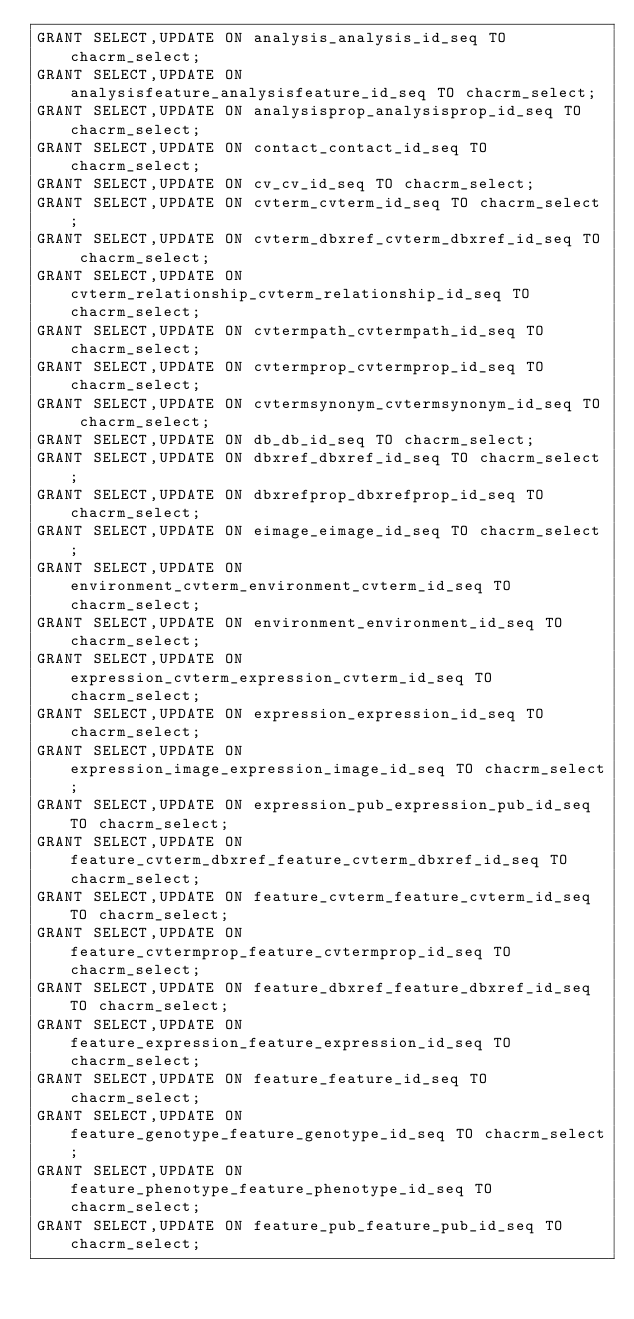<code> <loc_0><loc_0><loc_500><loc_500><_SQL_>GRANT SELECT,UPDATE ON analysis_analysis_id_seq TO chacrm_select;
GRANT SELECT,UPDATE ON analysisfeature_analysisfeature_id_seq TO chacrm_select;
GRANT SELECT,UPDATE ON analysisprop_analysisprop_id_seq TO chacrm_select;
GRANT SELECT,UPDATE ON contact_contact_id_seq TO chacrm_select;
GRANT SELECT,UPDATE ON cv_cv_id_seq TO chacrm_select;
GRANT SELECT,UPDATE ON cvterm_cvterm_id_seq TO chacrm_select;
GRANT SELECT,UPDATE ON cvterm_dbxref_cvterm_dbxref_id_seq TO chacrm_select;
GRANT SELECT,UPDATE ON cvterm_relationship_cvterm_relationship_id_seq TO chacrm_select;
GRANT SELECT,UPDATE ON cvtermpath_cvtermpath_id_seq TO chacrm_select;
GRANT SELECT,UPDATE ON cvtermprop_cvtermprop_id_seq TO chacrm_select;
GRANT SELECT,UPDATE ON cvtermsynonym_cvtermsynonym_id_seq TO chacrm_select;
GRANT SELECT,UPDATE ON db_db_id_seq TO chacrm_select;
GRANT SELECT,UPDATE ON dbxref_dbxref_id_seq TO chacrm_select;
GRANT SELECT,UPDATE ON dbxrefprop_dbxrefprop_id_seq TO chacrm_select;
GRANT SELECT,UPDATE ON eimage_eimage_id_seq TO chacrm_select;
GRANT SELECT,UPDATE ON environment_cvterm_environment_cvterm_id_seq TO chacrm_select;
GRANT SELECT,UPDATE ON environment_environment_id_seq TO chacrm_select;
GRANT SELECT,UPDATE ON expression_cvterm_expression_cvterm_id_seq TO chacrm_select;
GRANT SELECT,UPDATE ON expression_expression_id_seq TO chacrm_select;
GRANT SELECT,UPDATE ON expression_image_expression_image_id_seq TO chacrm_select;
GRANT SELECT,UPDATE ON expression_pub_expression_pub_id_seq TO chacrm_select;
GRANT SELECT,UPDATE ON feature_cvterm_dbxref_feature_cvterm_dbxref_id_seq TO chacrm_select;
GRANT SELECT,UPDATE ON feature_cvterm_feature_cvterm_id_seq TO chacrm_select;
GRANT SELECT,UPDATE ON feature_cvtermprop_feature_cvtermprop_id_seq TO chacrm_select;
GRANT SELECT,UPDATE ON feature_dbxref_feature_dbxref_id_seq TO chacrm_select;
GRANT SELECT,UPDATE ON feature_expression_feature_expression_id_seq TO chacrm_select;
GRANT SELECT,UPDATE ON feature_feature_id_seq TO chacrm_select;
GRANT SELECT,UPDATE ON feature_genotype_feature_genotype_id_seq TO chacrm_select;
GRANT SELECT,UPDATE ON feature_phenotype_feature_phenotype_id_seq TO chacrm_select;
GRANT SELECT,UPDATE ON feature_pub_feature_pub_id_seq TO chacrm_select;</code> 